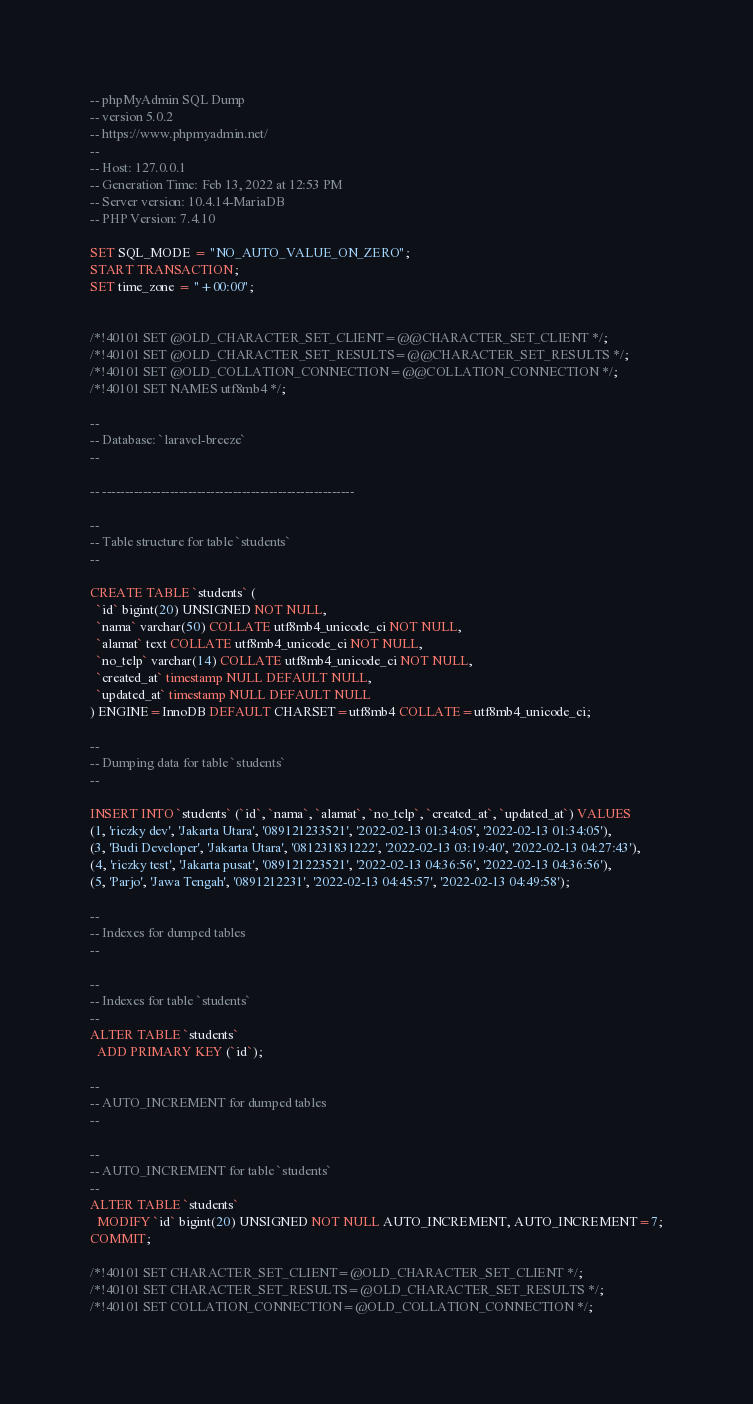<code> <loc_0><loc_0><loc_500><loc_500><_SQL_>-- phpMyAdmin SQL Dump
-- version 5.0.2
-- https://www.phpmyadmin.net/
--
-- Host: 127.0.0.1
-- Generation Time: Feb 13, 2022 at 12:53 PM
-- Server version: 10.4.14-MariaDB
-- PHP Version: 7.4.10

SET SQL_MODE = "NO_AUTO_VALUE_ON_ZERO";
START TRANSACTION;
SET time_zone = "+00:00";


/*!40101 SET @OLD_CHARACTER_SET_CLIENT=@@CHARACTER_SET_CLIENT */;
/*!40101 SET @OLD_CHARACTER_SET_RESULTS=@@CHARACTER_SET_RESULTS */;
/*!40101 SET @OLD_COLLATION_CONNECTION=@@COLLATION_CONNECTION */;
/*!40101 SET NAMES utf8mb4 */;

--
-- Database: `laravel-breeze`
--

-- --------------------------------------------------------

--
-- Table structure for table `students`
--

CREATE TABLE `students` (
  `id` bigint(20) UNSIGNED NOT NULL,
  `nama` varchar(50) COLLATE utf8mb4_unicode_ci NOT NULL,
  `alamat` text COLLATE utf8mb4_unicode_ci NOT NULL,
  `no_telp` varchar(14) COLLATE utf8mb4_unicode_ci NOT NULL,
  `created_at` timestamp NULL DEFAULT NULL,
  `updated_at` timestamp NULL DEFAULT NULL
) ENGINE=InnoDB DEFAULT CHARSET=utf8mb4 COLLATE=utf8mb4_unicode_ci;

--
-- Dumping data for table `students`
--

INSERT INTO `students` (`id`, `nama`, `alamat`, `no_telp`, `created_at`, `updated_at`) VALUES
(1, 'riczky dev', 'Jakarta Utara', '089121233521', '2022-02-13 01:34:05', '2022-02-13 01:34:05'),
(3, 'Budi Developer', 'Jakarta Utara', '081231831222', '2022-02-13 03:19:40', '2022-02-13 04:27:43'),
(4, 'riczky test', 'Jakarta pusat', '089121223521', '2022-02-13 04:36:56', '2022-02-13 04:36:56'),
(5, 'Parjo', 'Jawa Tengah', '0891212231', '2022-02-13 04:45:57', '2022-02-13 04:49:58');

--
-- Indexes for dumped tables
--

--
-- Indexes for table `students`
--
ALTER TABLE `students`
  ADD PRIMARY KEY (`id`);

--
-- AUTO_INCREMENT for dumped tables
--

--
-- AUTO_INCREMENT for table `students`
--
ALTER TABLE `students`
  MODIFY `id` bigint(20) UNSIGNED NOT NULL AUTO_INCREMENT, AUTO_INCREMENT=7;
COMMIT;

/*!40101 SET CHARACTER_SET_CLIENT=@OLD_CHARACTER_SET_CLIENT */;
/*!40101 SET CHARACTER_SET_RESULTS=@OLD_CHARACTER_SET_RESULTS */;
/*!40101 SET COLLATION_CONNECTION=@OLD_COLLATION_CONNECTION */;
</code> 